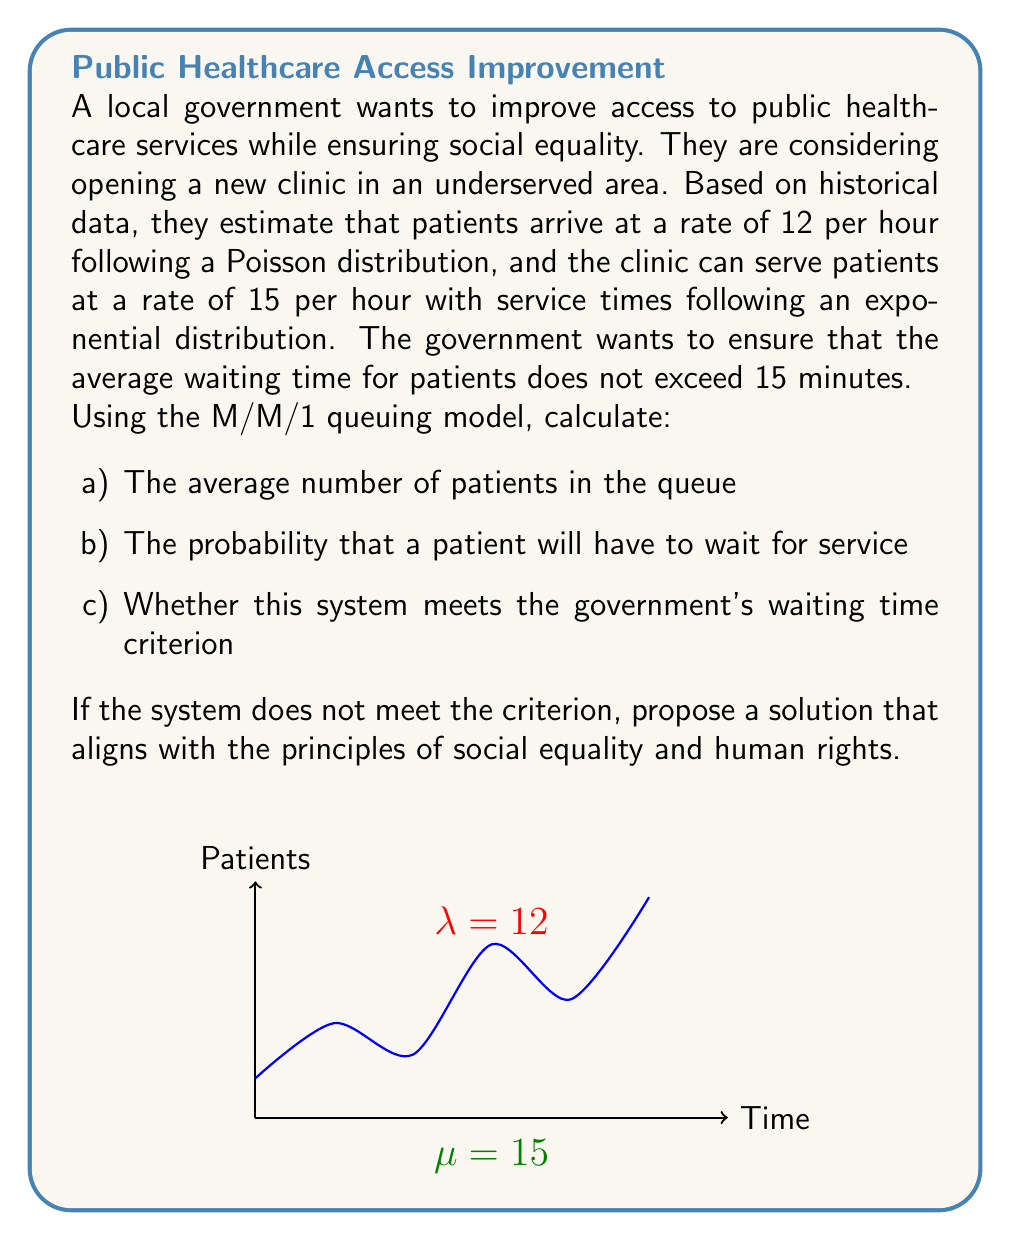Can you answer this question? Let's approach this step-by-step using the M/M/1 queuing model:

1) First, we need to calculate the utilization factor ρ:
   $$\rho = \frac{\lambda}{\mu}$$
   where λ is the arrival rate and μ is the service rate
   $$\rho = \frac{12}{15} = 0.8$$

2) The average number of patients in the queue (Lq) is given by:
   $$L_q = \frac{\rho^2}{1-\rho} = \frac{0.8^2}{1-0.8} = \frac{0.64}{0.2} = 3.2$$

3) The probability that a patient will have to wait (Pw) is equal to the utilization factor:
   $$P_w = \rho = 0.8 = 80\%$$

4) To check if the system meets the waiting time criterion, we need to calculate the average waiting time (Wq):
   $$W_q = \frac{L_q}{\lambda} = \frac{3.2}{12} = 0.2667 \text{ hours} = 16 \text{ minutes}$$

   This exceeds the 15-minute criterion set by the government.

5) To meet the criterion, we need to increase the service rate. Let's calculate the required service rate:

   We want Wq ≤ 0.25 hours (15 minutes)
   $$0.25 \geq \frac{\rho^2}{\mu(1-\rho)}$$
   $$0.25\mu - 0.25\mu\rho \geq \rho^2$$
   $$0.25\mu - 0.25\mu\frac{\lambda}{\mu} \geq (\frac{\lambda}{\mu})^2$$
   $$0.25\mu - 3 \geq \frac{144}{\mu}$$

   Solving this quadratic equation, we get μ ≈ 16.97

6) A solution that aligns with social equality and human rights would be to increase the service rate to 17 patients per hour. This could be achieved by:
   - Hiring additional medical staff
   - Improving efficiency through better technology or processes
   - Extending clinic hours to distribute patient load

This solution ensures equal access to healthcare while maintaining service quality for all patients.
Answer: a) 3.2 patients
b) 80%
c) No; Increase service rate to 17 patients/hour 